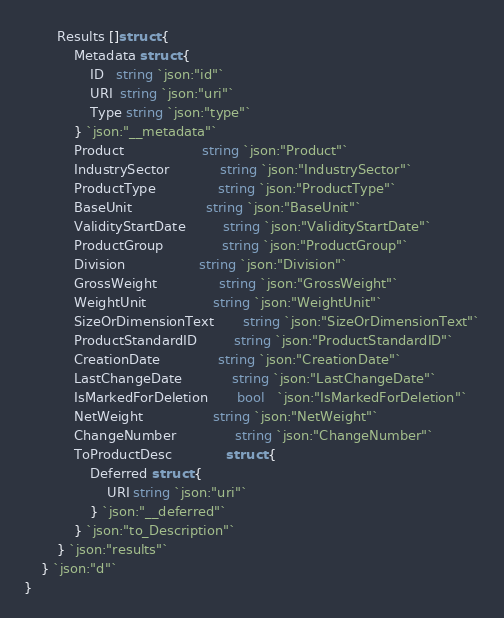Convert code to text. <code><loc_0><loc_0><loc_500><loc_500><_Go_>		Results []struct {
			Metadata struct {
				ID   string `json:"id"`
				URI  string `json:"uri"`
				Type string `json:"type"`
			} `json:"__metadata"`
			Product                   string `json:"Product"`
			IndustrySector            string `json:"IndustrySector"`
			ProductType               string `json:"ProductType"`
			BaseUnit                  string `json:"BaseUnit"`
			ValidityStartDate         string `json:"ValidityStartDate"`
			ProductGroup              string `json:"ProductGroup"`
			Division                  string `json:"Division"`
			GrossWeight               string `json:"GrossWeight"`
			WeightUnit                string `json:"WeightUnit"`
			SizeOrDimensionText       string `json:"SizeOrDimensionText"`
			ProductStandardID         string `json:"ProductStandardID"`
			CreationDate              string `json:"CreationDate"`
			LastChangeDate            string `json:"LastChangeDate"`
			IsMarkedForDeletion       bool   `json:"IsMarkedForDeletion"`
			NetWeight                 string `json:"NetWeight"`
			ChangeNumber              string `json:"ChangeNumber"`
			ToProductDesc             struct {
				Deferred struct {
					URI string `json:"uri"`
				} `json:"__deferred"`
			} `json:"to_Description"`
		} `json:"results"`
	} `json:"d"`
}
</code> 